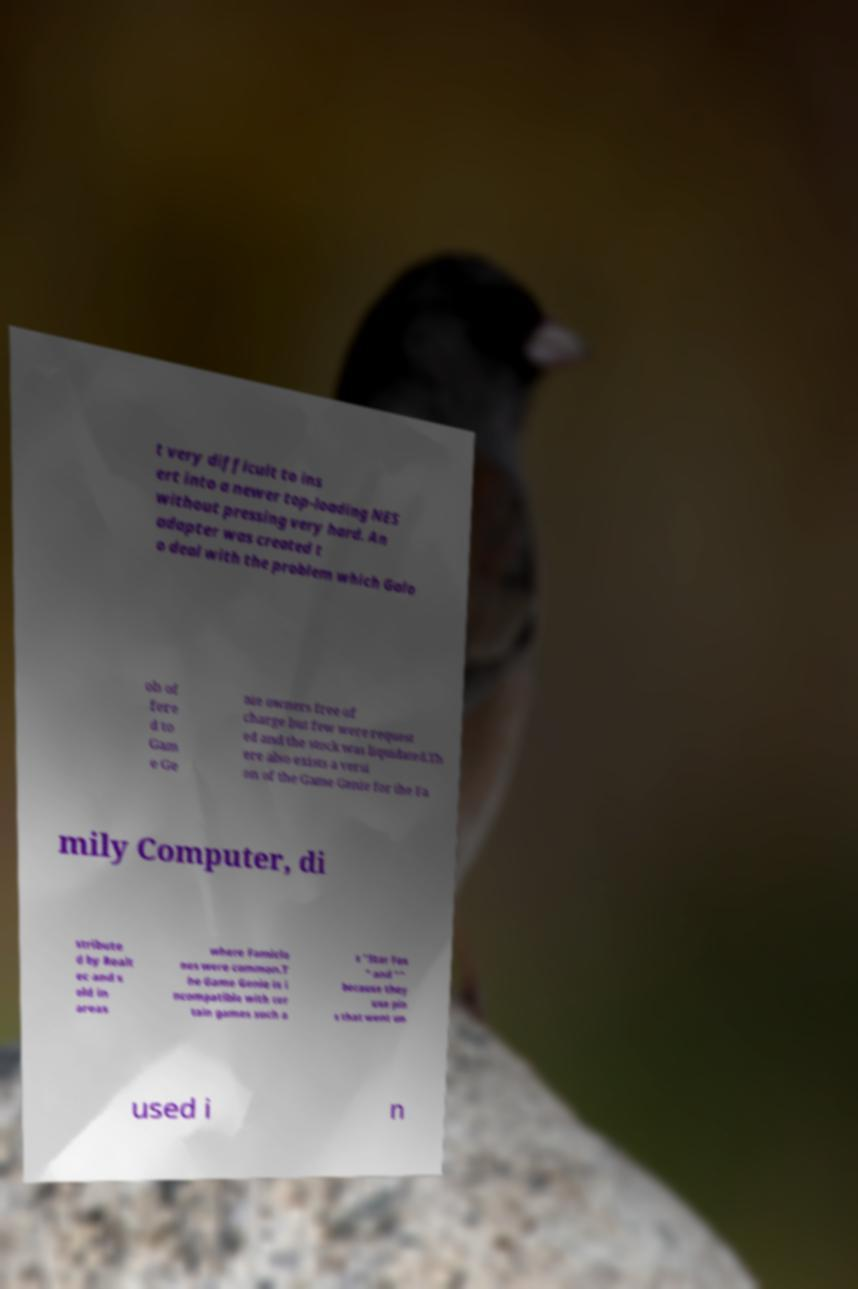Could you extract and type out the text from this image? t very difficult to ins ert into a newer top-loading NES without pressing very hard. An adapter was created t o deal with the problem which Galo ob of fere d to Gam e Ge nie owners free of charge but few were request ed and the stock was liquidated.Th ere also exists a versi on of the Game Genie for the Fa mily Computer, di stribute d by Realt ec and s old in areas where Famiclo nes were common.T he Game Genie is i ncompatible with cer tain games such a s "Star Fox " and "" because they use pin s that went un used i n 